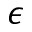Convert formula to latex. <formula><loc_0><loc_0><loc_500><loc_500>\epsilon</formula> 